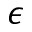Convert formula to latex. <formula><loc_0><loc_0><loc_500><loc_500>\epsilon</formula> 